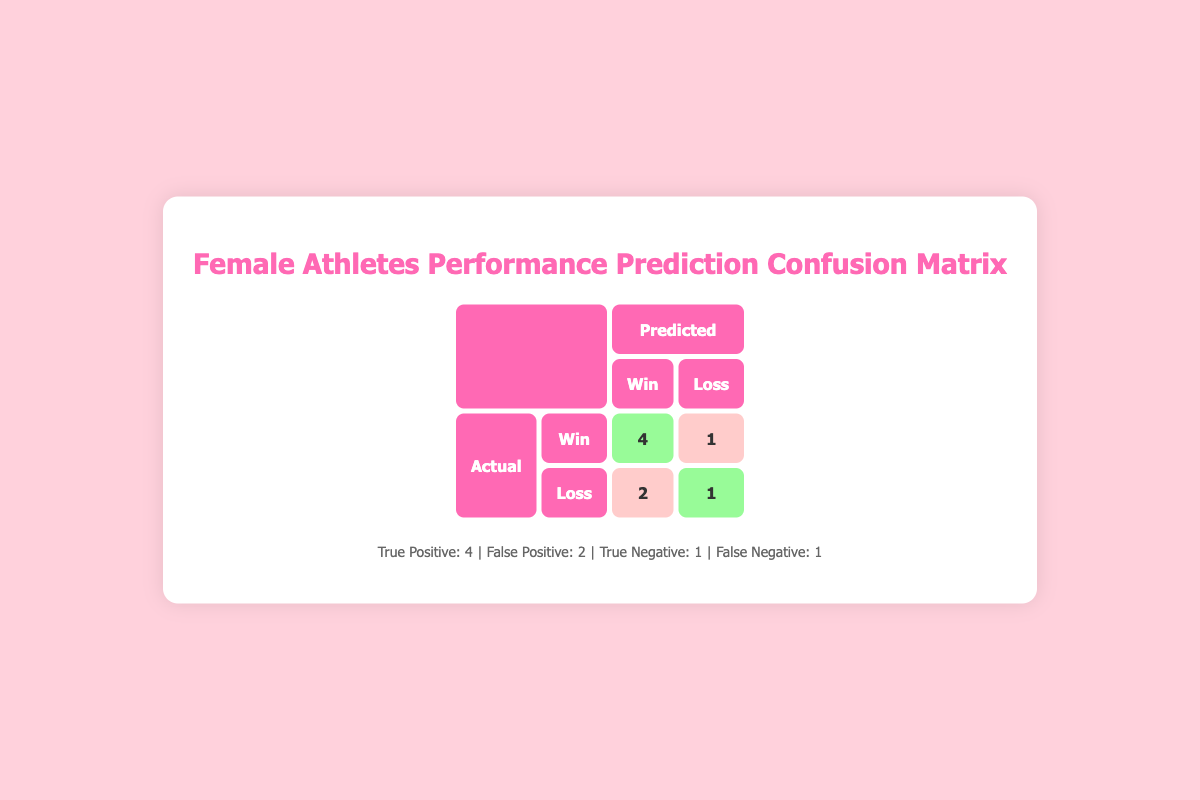What is the total number of true positives? The table indicates that there are 4 true positives, representing the athletes who were predicted to win and actually won.
Answer: 4 How many athletes were predicted to lose? The table shows that there are 3 athletes predicted to lose (Sandi Morris, Kendra Harrison, and Shelly-Ann Fraser-Pryce), as they are listed under the "Loss" category in the "predicted performance" row.
Answer: 3 What is the number of false negatives? The table lists 1 false negative, which represents the one athlete who was predicted to lose but actually won (Sandi Morris).
Answer: 1 Did Elaine Thompson-Herah meet her predicted performance? Yes, Elaine Thompson-Herah was predicted to win and did win, confirming her predicted performance.
Answer: Yes If the total number of athletes is 8, what is the percentage of true negatives? There is 1 true negative from the table. To find the percentage, divide the number of true negatives by the total athletes: (1/8) * 100 = 12.5%.
Answer: 12.5% What is the difference between true positives and false positives? There are 4 true positives and 2 false positives. The difference would be 4 - 2 = 2. This means that there are 2 more athletes who succeeded than those predicted to succeed but actually failed.
Answer: 2 How many athletes had an actual performance of "Win"? By reviewing the table, we see 5 athletes had an actual performance of "Win" (Elaine Thompson-Herah, Mary Moraa, Brittney Reese, Maria Lasitskene, and Sandi Morris).
Answer: 5 Among the athletes listed in the table, who were predicted to win and didn't? Kendra Harrison and Shelly-Ann Fraser-Pryce were both predicted to win but did not meet that expectation, as Kendra lost and Shelly-Ann also lost.
Answer: Kendra Harrison and Shelly-Ann Fraser-Pryce 